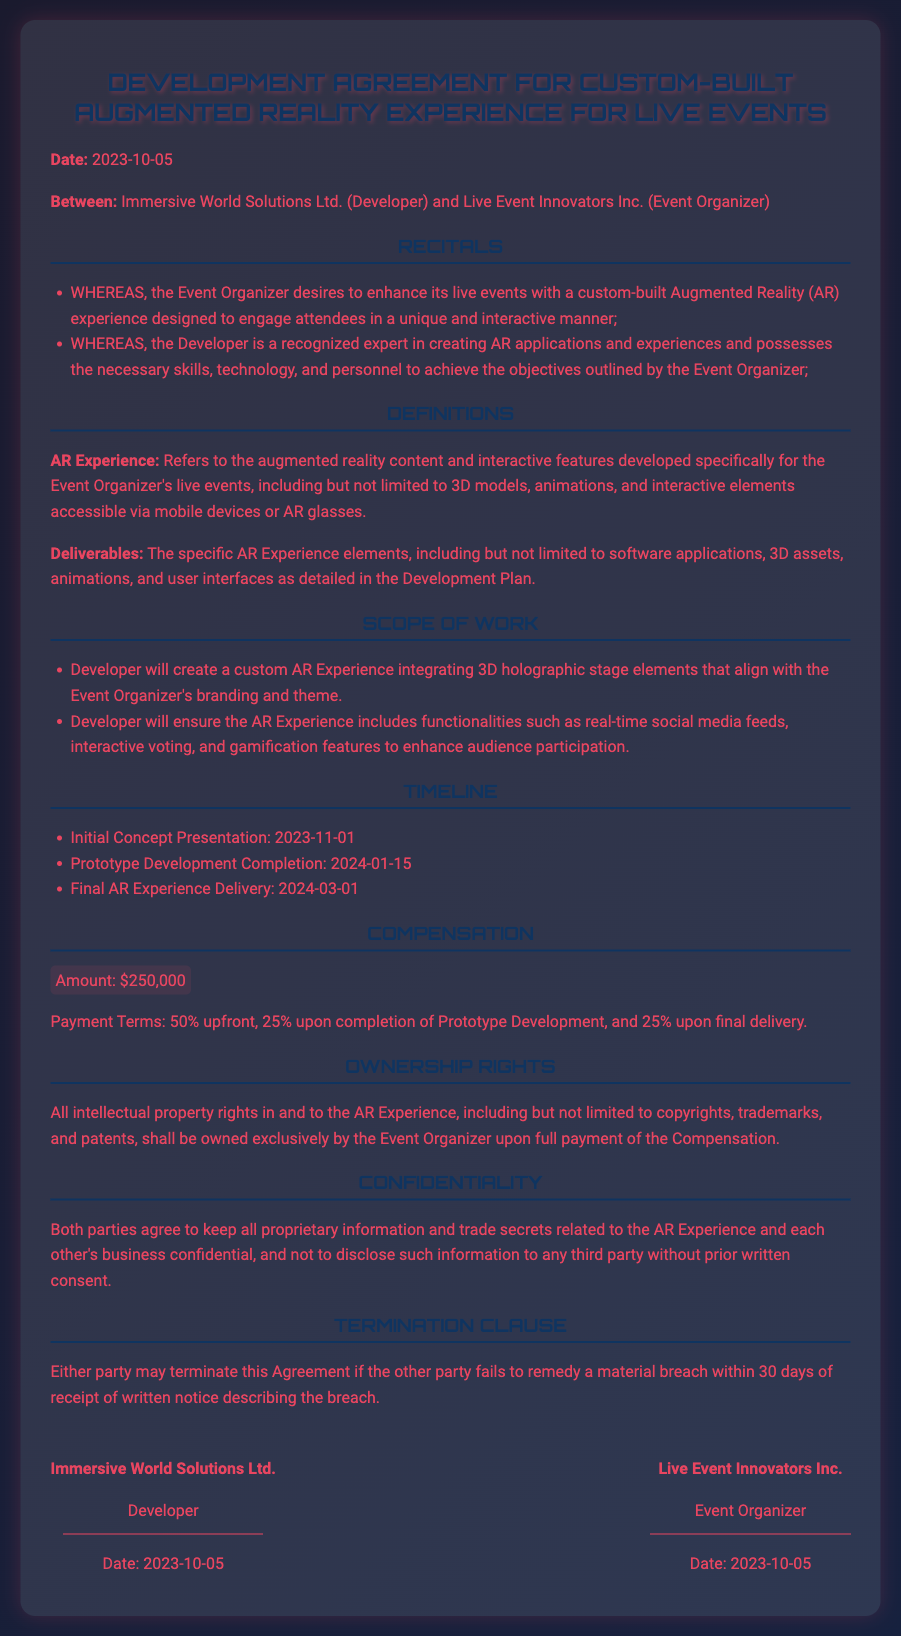What is the date of the agreement? The date is mentioned in the opening as the effective date of the agreement, which is 2023-10-05.
Answer: 2023-10-05 Who is the Developer? The Developer is identified at the beginning of the document as Immersive World Solutions Ltd.
Answer: Immersive World Solutions Ltd What is the total amount of compensation? The total compensation amount is stated in the Compensation section of the document, which is $250,000.
Answer: $250,000 When is the Final AR Experience Delivery date? The Final AR Experience Delivery date is explicitly listed in the Timeline section as 2024-03-01.
Answer: 2024-03-01 What are the payment terms? The payment terms detail the schedule and amounts of payments, which include specific percentages upon milestone achievements.
Answer: 50% upfront, 25% upon completion of Prototype Development, and 25% upon final delivery What intellectual property rights are mentioned? The document mentions that all intellectual property rights shall be owned exclusively by the Event Organizer upon full payment.
Answer: Owned exclusively by the Event Organizer What is the purpose of this agreement? The purpose is to enhance live events with a custom-built Augmented Reality (AR) experience to engage attendees.
Answer: To enhance live events with a custom-built Augmented Reality experience What happens if a party breaches the agreement? The Termination Clause states either party may terminate if the other fails to remedy a material breach within 30 days.
Answer: 30 days Who will own the AR Experience after full payment? The ownership of the AR Experience is clarified, stating that it shall be owned by the Event Organizer.
Answer: Event Organizer 